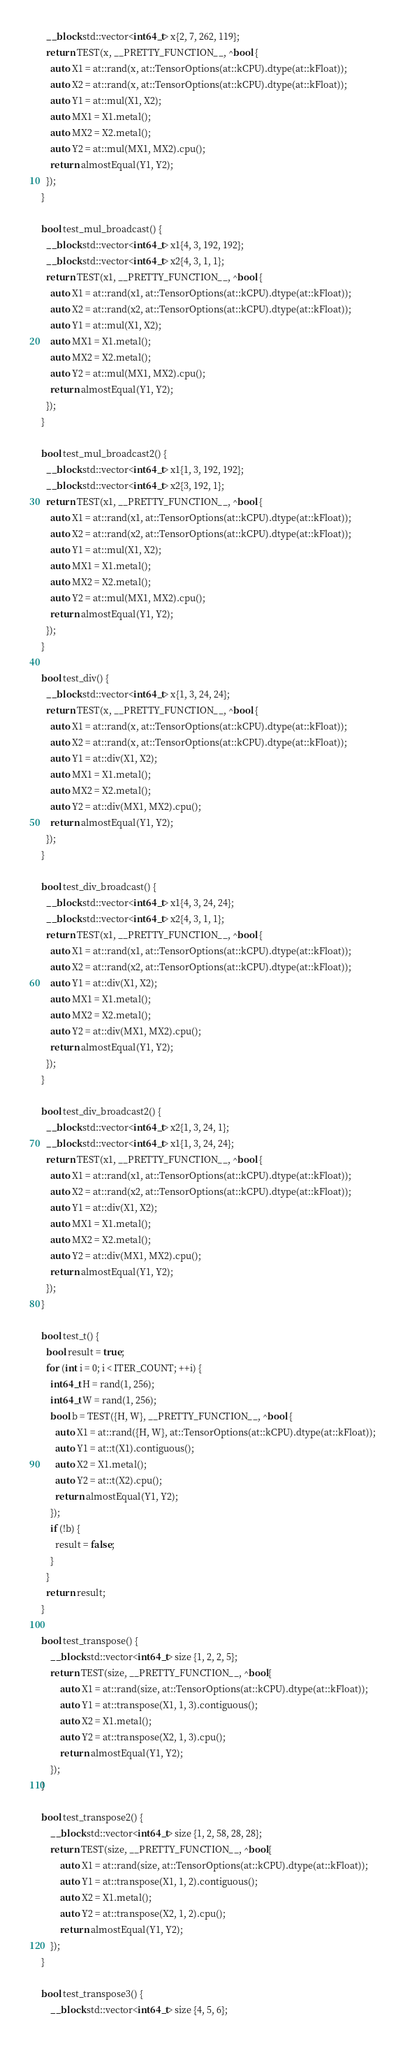<code> <loc_0><loc_0><loc_500><loc_500><_ObjectiveC_>  __block std::vector<int64_t> x{2, 7, 262, 119};
  return TEST(x, __PRETTY_FUNCTION__, ^bool {
    auto X1 = at::rand(x, at::TensorOptions(at::kCPU).dtype(at::kFloat));
    auto X2 = at::rand(x, at::TensorOptions(at::kCPU).dtype(at::kFloat));
    auto Y1 = at::mul(X1, X2);
    auto MX1 = X1.metal();
    auto MX2 = X2.metal();
    auto Y2 = at::mul(MX1, MX2).cpu();
    return almostEqual(Y1, Y2);
  });
}

bool test_mul_broadcast() {
  __block std::vector<int64_t> x1{4, 3, 192, 192};
  __block std::vector<int64_t> x2{4, 3, 1, 1};
  return TEST(x1, __PRETTY_FUNCTION__, ^bool {
    auto X1 = at::rand(x1, at::TensorOptions(at::kCPU).dtype(at::kFloat));
    auto X2 = at::rand(x2, at::TensorOptions(at::kCPU).dtype(at::kFloat));
    auto Y1 = at::mul(X1, X2);
    auto MX1 = X1.metal();
    auto MX2 = X2.metal();
    auto Y2 = at::mul(MX1, MX2).cpu();
    return almostEqual(Y1, Y2);
  });
}

bool test_mul_broadcast2() {
  __block std::vector<int64_t> x1{1, 3, 192, 192};
  __block std::vector<int64_t> x2{3, 192, 1};
  return TEST(x1, __PRETTY_FUNCTION__, ^bool {
    auto X1 = at::rand(x1, at::TensorOptions(at::kCPU).dtype(at::kFloat));
    auto X2 = at::rand(x2, at::TensorOptions(at::kCPU).dtype(at::kFloat));
    auto Y1 = at::mul(X1, X2);
    auto MX1 = X1.metal();
    auto MX2 = X2.metal();
    auto Y2 = at::mul(MX1, MX2).cpu();
    return almostEqual(Y1, Y2);
  });
}

bool test_div() {
  __block std::vector<int64_t> x{1, 3, 24, 24};
  return TEST(x, __PRETTY_FUNCTION__, ^bool {
    auto X1 = at::rand(x, at::TensorOptions(at::kCPU).dtype(at::kFloat));
    auto X2 = at::rand(x, at::TensorOptions(at::kCPU).dtype(at::kFloat));
    auto Y1 = at::div(X1, X2);
    auto MX1 = X1.metal();
    auto MX2 = X2.metal();
    auto Y2 = at::div(MX1, MX2).cpu();
    return almostEqual(Y1, Y2);
  });
}

bool test_div_broadcast() {
  __block std::vector<int64_t> x1{4, 3, 24, 24};
  __block std::vector<int64_t> x2{4, 3, 1, 1};
  return TEST(x1, __PRETTY_FUNCTION__, ^bool {
    auto X1 = at::rand(x1, at::TensorOptions(at::kCPU).dtype(at::kFloat));
    auto X2 = at::rand(x2, at::TensorOptions(at::kCPU).dtype(at::kFloat));
    auto Y1 = at::div(X1, X2);
    auto MX1 = X1.metal();
    auto MX2 = X2.metal();
    auto Y2 = at::div(MX1, MX2).cpu();
    return almostEqual(Y1, Y2);
  });
}

bool test_div_broadcast2() {
  __block std::vector<int64_t> x2{1, 3, 24, 1};
  __block std::vector<int64_t> x1{1, 3, 24, 24};
  return TEST(x1, __PRETTY_FUNCTION__, ^bool {
    auto X1 = at::rand(x1, at::TensorOptions(at::kCPU).dtype(at::kFloat));
    auto X2 = at::rand(x2, at::TensorOptions(at::kCPU).dtype(at::kFloat));
    auto Y1 = at::div(X1, X2);
    auto MX1 = X1.metal();
    auto MX2 = X2.metal();
    auto Y2 = at::div(MX1, MX2).cpu();
    return almostEqual(Y1, Y2);
  });
}

bool test_t() {
  bool result = true;
  for (int i = 0; i < ITER_COUNT; ++i) {
    int64_t H = rand(1, 256);
    int64_t W = rand(1, 256);
    bool b = TEST({H, W}, __PRETTY_FUNCTION__, ^bool {
      auto X1 = at::rand({H, W}, at::TensorOptions(at::kCPU).dtype(at::kFloat));
      auto Y1 = at::t(X1).contiguous();
      auto X2 = X1.metal();
      auto Y2 = at::t(X2).cpu();
      return almostEqual(Y1, Y2);
    });
    if (!b) {
      result = false;
    }
  }
  return result;
}

bool test_transpose() {
    __block std::vector<int64_t> size {1, 2, 2, 5};
    return TEST(size, __PRETTY_FUNCTION__, ^bool{
        auto X1 = at::rand(size, at::TensorOptions(at::kCPU).dtype(at::kFloat));
        auto Y1 = at::transpose(X1, 1, 3).contiguous();
        auto X2 = X1.metal();
        auto Y2 = at::transpose(X2, 1, 3).cpu();
        return almostEqual(Y1, Y2);
    });
}

bool test_transpose2() {
    __block std::vector<int64_t> size {1, 2, 58, 28, 28};
    return TEST(size, __PRETTY_FUNCTION__, ^bool{
        auto X1 = at::rand(size, at::TensorOptions(at::kCPU).dtype(at::kFloat));
        auto Y1 = at::transpose(X1, 1, 2).contiguous();
        auto X2 = X1.metal();
        auto Y2 = at::transpose(X2, 1, 2).cpu();
        return almostEqual(Y1, Y2);
    });
}

bool test_transpose3() {
    __block std::vector<int64_t> size {4, 5, 6};</code> 